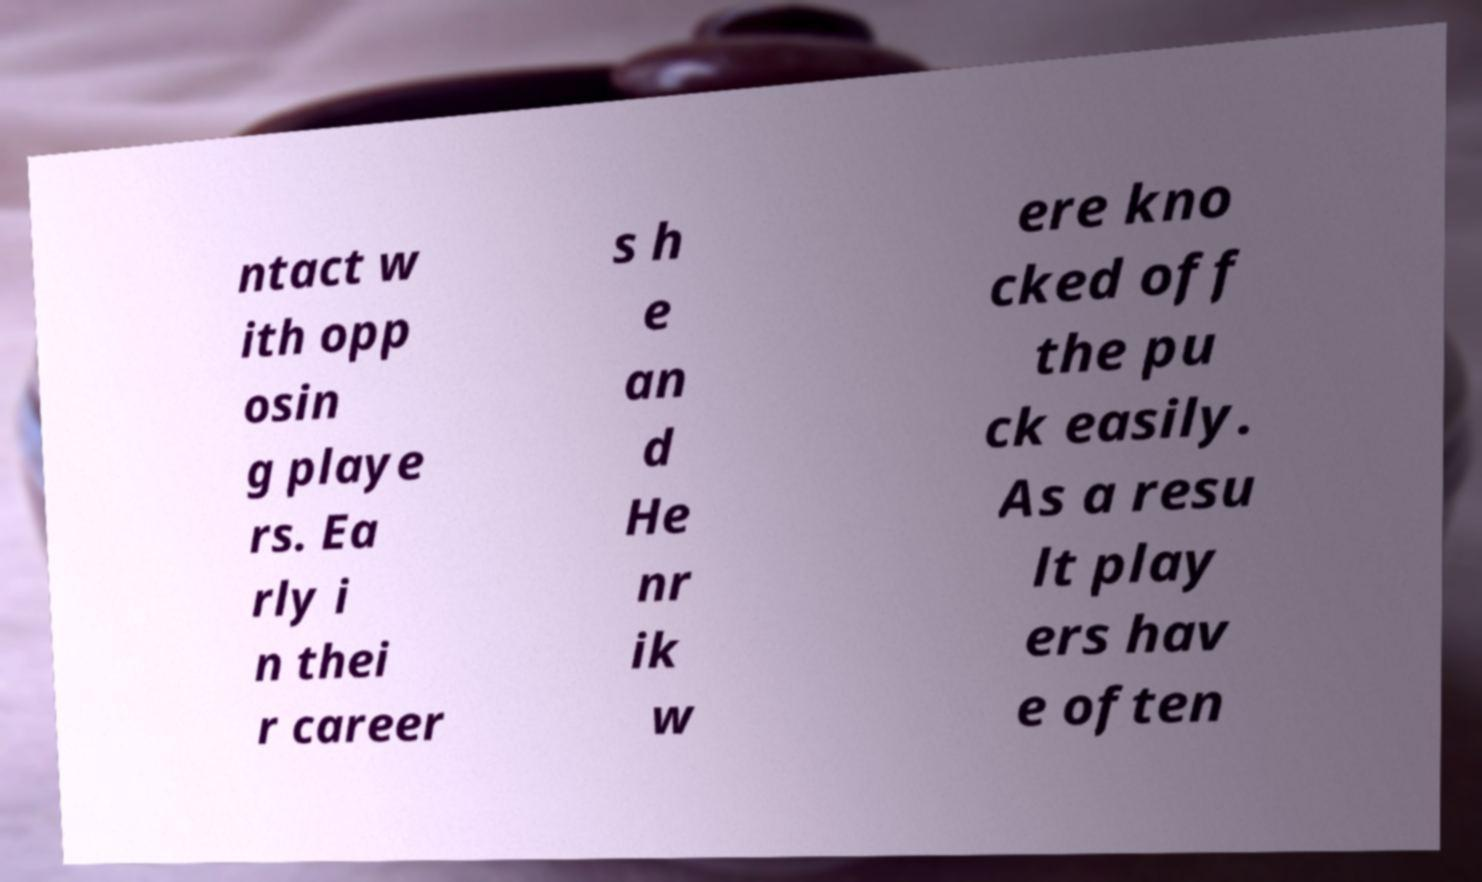For documentation purposes, I need the text within this image transcribed. Could you provide that? ntact w ith opp osin g playe rs. Ea rly i n thei r career s h e an d He nr ik w ere kno cked off the pu ck easily. As a resu lt play ers hav e often 